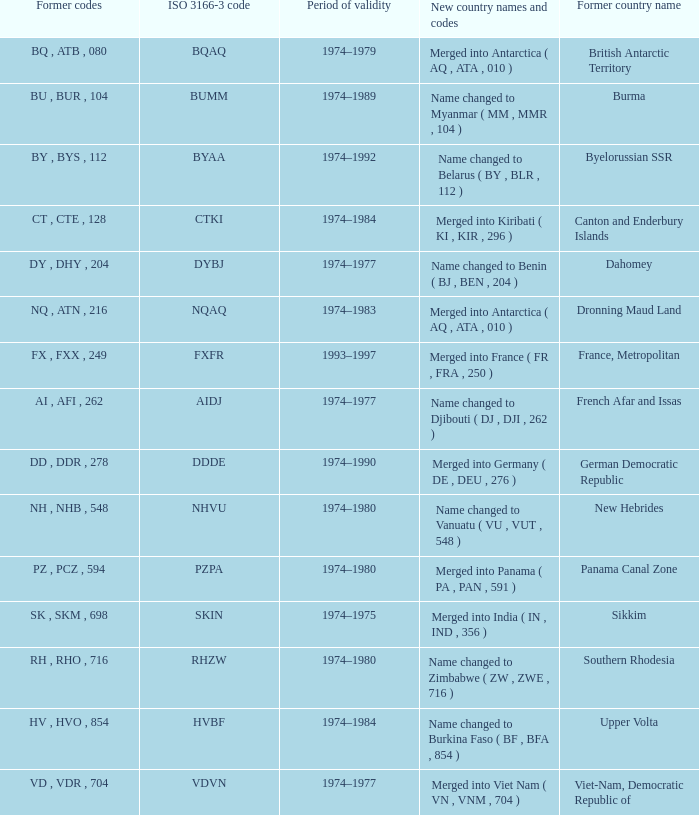List the earlier codes that were consolidated into panama (pa, pan, 591) PZ , PCZ , 594. Help me parse the entirety of this table. {'header': ['Former codes', 'ISO 3166-3 code', 'Period of validity', 'New country names and codes', 'Former country name'], 'rows': [['BQ , ATB , 080', 'BQAQ', '1974–1979', 'Merged into Antarctica ( AQ , ATA , 010 )', 'British Antarctic Territory'], ['BU , BUR , 104', 'BUMM', '1974–1989', 'Name changed to Myanmar ( MM , MMR , 104 )', 'Burma'], ['BY , BYS , 112', 'BYAA', '1974–1992', 'Name changed to Belarus ( BY , BLR , 112 )', 'Byelorussian SSR'], ['CT , CTE , 128', 'CTKI', '1974–1984', 'Merged into Kiribati ( KI , KIR , 296 )', 'Canton and Enderbury Islands'], ['DY , DHY , 204', 'DYBJ', '1974–1977', 'Name changed to Benin ( BJ , BEN , 204 )', 'Dahomey'], ['NQ , ATN , 216', 'NQAQ', '1974–1983', 'Merged into Antarctica ( AQ , ATA , 010 )', 'Dronning Maud Land'], ['FX , FXX , 249', 'FXFR', '1993–1997', 'Merged into France ( FR , FRA , 250 )', 'France, Metropolitan'], ['AI , AFI , 262', 'AIDJ', '1974–1977', 'Name changed to Djibouti ( DJ , DJI , 262 )', 'French Afar and Issas'], ['DD , DDR , 278', 'DDDE', '1974–1990', 'Merged into Germany ( DE , DEU , 276 )', 'German Democratic Republic'], ['NH , NHB , 548', 'NHVU', '1974–1980', 'Name changed to Vanuatu ( VU , VUT , 548 )', 'New Hebrides'], ['PZ , PCZ , 594', 'PZPA', '1974–1980', 'Merged into Panama ( PA , PAN , 591 )', 'Panama Canal Zone'], ['SK , SKM , 698', 'SKIN', '1974–1975', 'Merged into India ( IN , IND , 356 )', 'Sikkim'], ['RH , RHO , 716', 'RHZW', '1974–1980', 'Name changed to Zimbabwe ( ZW , ZWE , 716 )', 'Southern Rhodesia'], ['HV , HVO , 854', 'HVBF', '1974–1984', 'Name changed to Burkina Faso ( BF , BFA , 854 )', 'Upper Volta'], ['VD , VDR , 704', 'VDVN', '1974–1977', 'Merged into Viet Nam ( VN , VNM , 704 )', 'Viet-Nam, Democratic Republic of']]} 